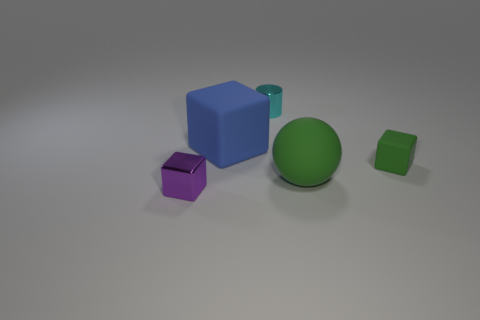Subtract all green cubes. How many cubes are left? 2 Subtract all purple cubes. How many cubes are left? 2 Add 4 metal cylinders. How many objects exist? 9 Subtract all cubes. How many objects are left? 2 Subtract all tiny matte cubes. Subtract all small purple metal blocks. How many objects are left? 3 Add 4 blocks. How many blocks are left? 7 Add 5 small cyan cylinders. How many small cyan cylinders exist? 6 Subtract 1 blue blocks. How many objects are left? 4 Subtract all brown cubes. Subtract all red spheres. How many cubes are left? 3 Subtract all brown blocks. How many red cylinders are left? 0 